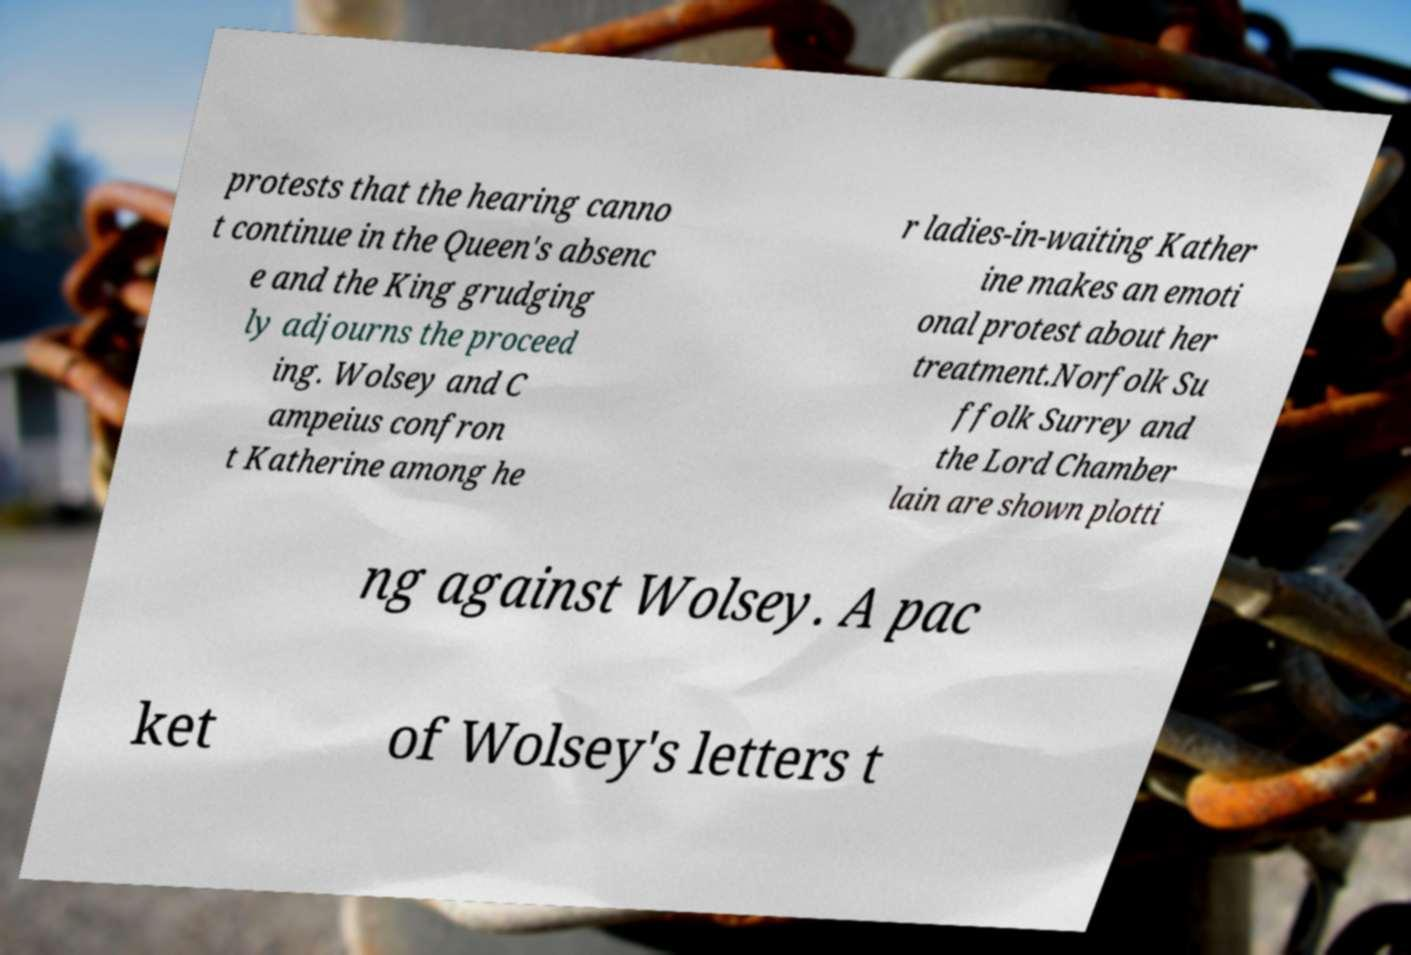Can you accurately transcribe the text from the provided image for me? protests that the hearing canno t continue in the Queen's absenc e and the King grudging ly adjourns the proceed ing. Wolsey and C ampeius confron t Katherine among he r ladies-in-waiting Kather ine makes an emoti onal protest about her treatment.Norfolk Su ffolk Surrey and the Lord Chamber lain are shown plotti ng against Wolsey. A pac ket of Wolsey's letters t 